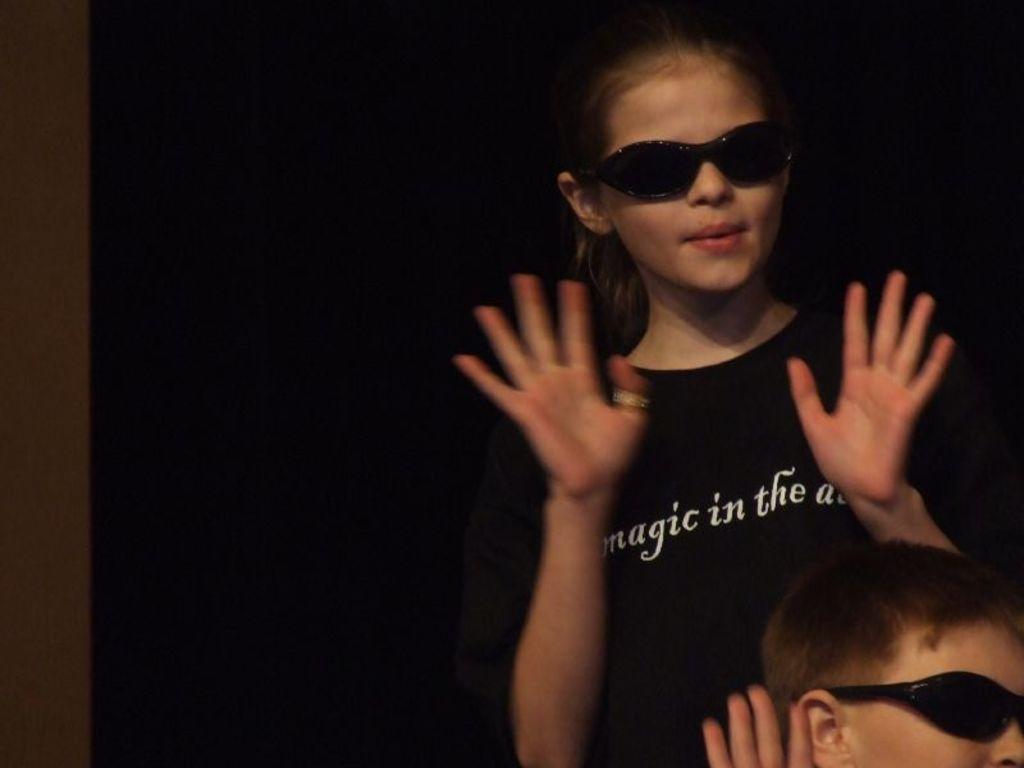How would you summarize this image in a sentence or two? In this image I can see two people. The person in front wearing black color shirt and I can see dark background. 